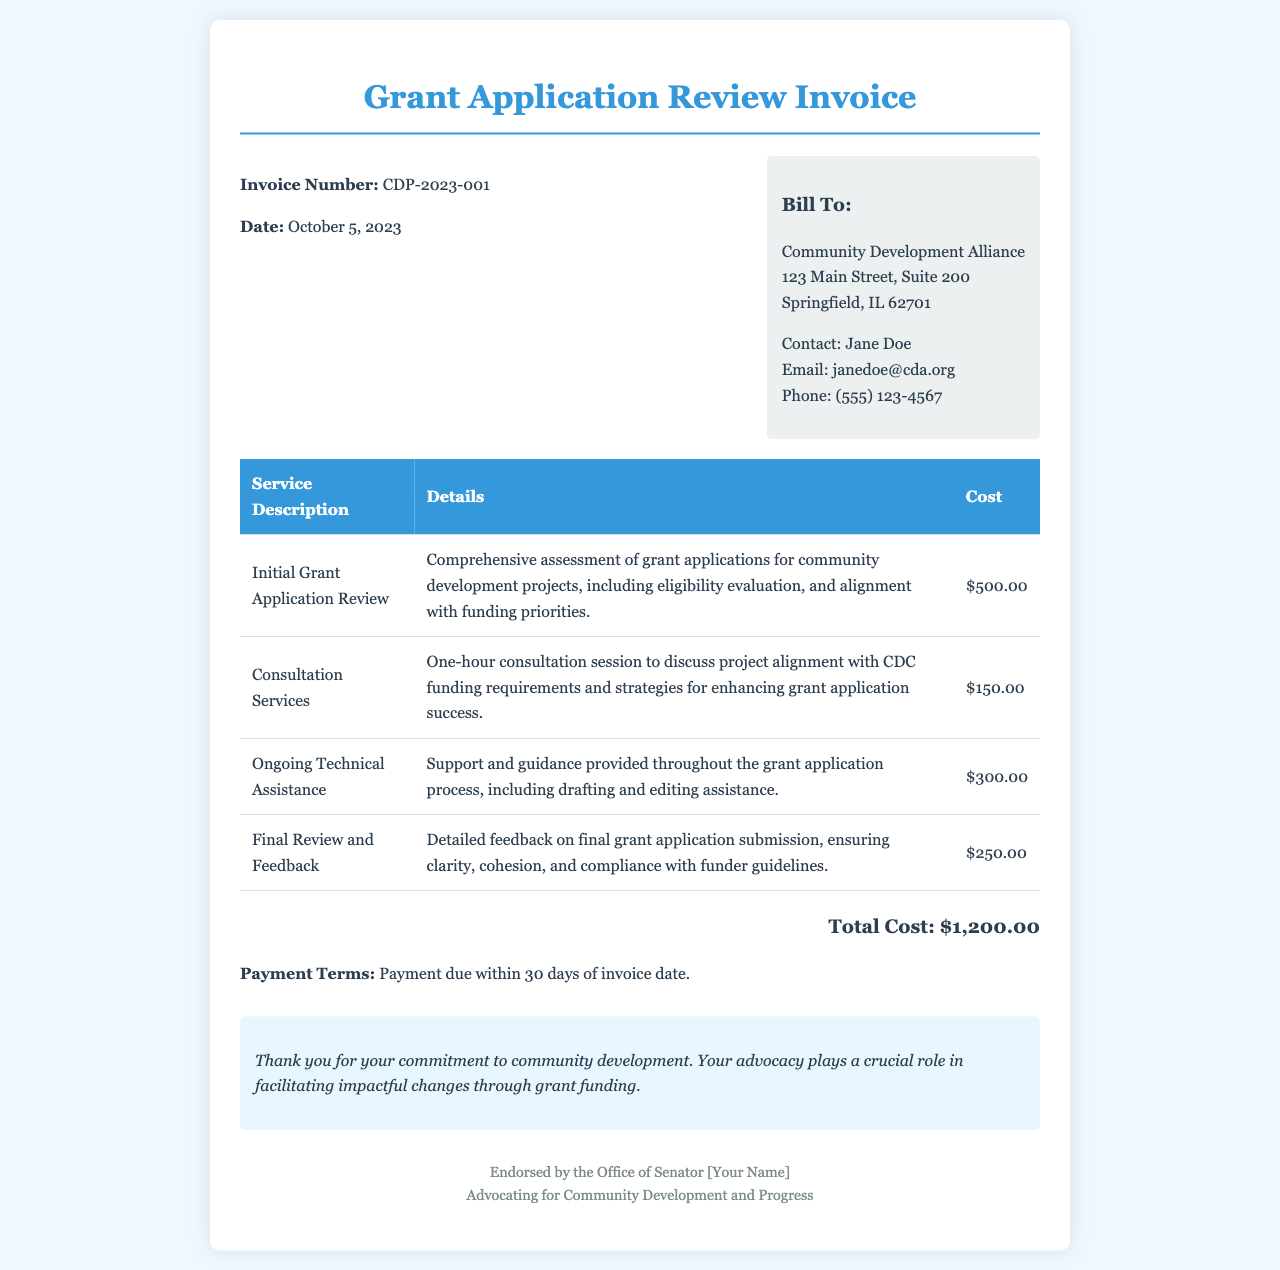What is the invoice number? The invoice number is used to identify the transaction and is listed as CDP-2023-001 in the document.
Answer: CDP-2023-001 Who is the invoice addressed to? The invoice is addressed to the organization receiving the bill, which in this document is the Community Development Alliance.
Answer: Community Development Alliance What is the total cost? The total cost represents the aggregate amount due for the services provided, which is mentioned clearly at the end of the invoice.
Answer: $1,200.00 What service has the highest cost? The costs of the services provided have been disclosed, with the Initial Grant Application Review being the most expensive.
Answer: Initial Grant Application Review What is the payment term? The payment term outlines the conditions under which payment should be made, specifically detailing the time frame for payment.
Answer: Payment due within 30 days of invoice date How many services are listed in the invoice? The invoice details multiple services provided, and these can be counted within the document’s service description table.
Answer: Four What is the cost for the Final Review and Feedback service? The cost for each service is specified in the invoice, and the amount for the Final Review and Feedback can be extracted directly from that section.
Answer: $250.00 What is included in the notes section? The notes section provides additional information expressing thanks and emphasizing the importance of advocacy in community development.
Answer: Thank you for your commitment to community development What date was the invoice created? The date of creation for the invoice is an essential element, usually presented prominently on the document.
Answer: October 5, 2023 What type of document is this? The type of document is significant as it identifies its main purpose and structure, which is specifically for billing charges related to grant application reviews.
Answer: Invoice 